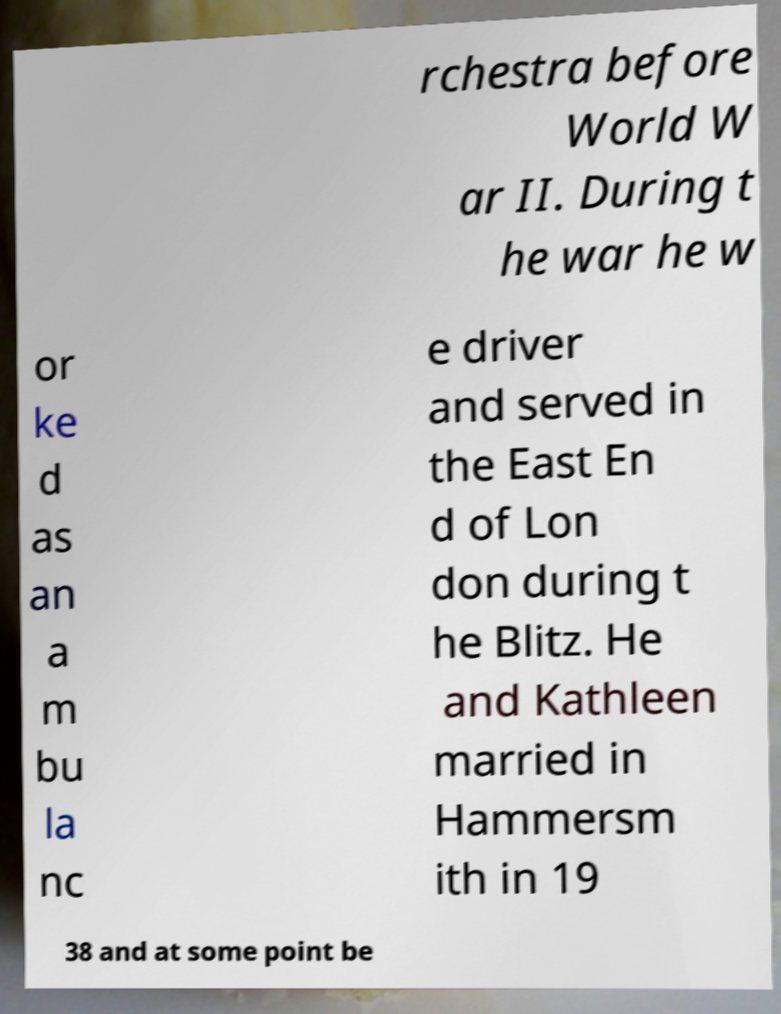Please identify and transcribe the text found in this image. rchestra before World W ar II. During t he war he w or ke d as an a m bu la nc e driver and served in the East En d of Lon don during t he Blitz. He and Kathleen married in Hammersm ith in 19 38 and at some point be 